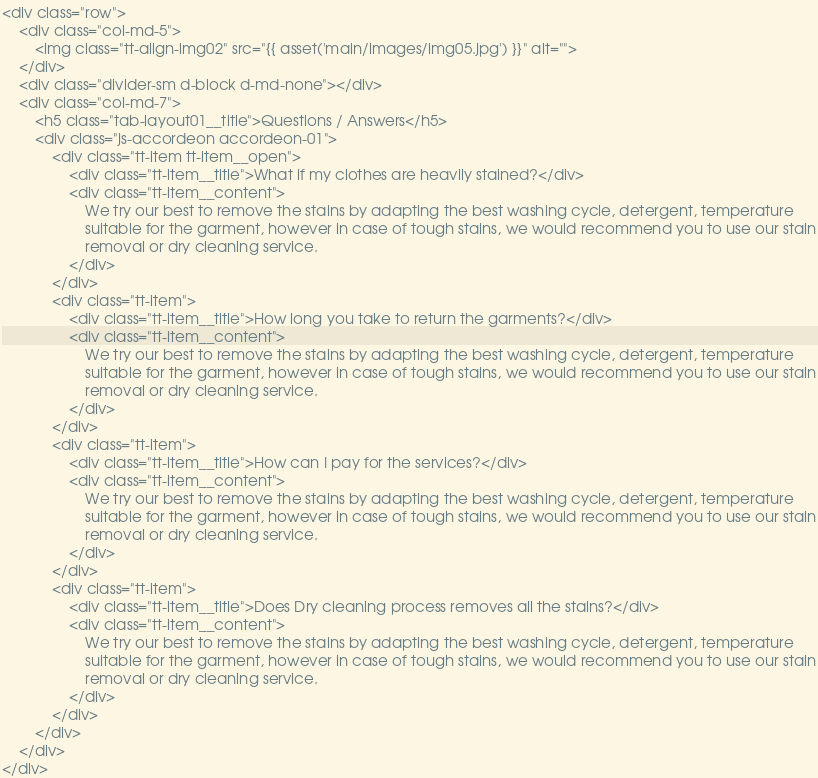<code> <loc_0><loc_0><loc_500><loc_500><_PHP_><div class="row">
    <div class="col-md-5">
        <img class="tt-align-img02" src="{{ asset('main/images/img05.jpg') }}" alt="">
    </div>
    <div class="divider-sm d-block d-md-none"></div>
    <div class="col-md-7">
        <h5 class="tab-layout01__title">Questions / Answers</h5>
        <div class="js-accordeon accordeon-01">
            <div class="tt-item tt-item__open">
                <div class="tt-item__title">What if my clothes are heavily stained?</div>
                <div class="tt-item__content">
                    We try our best to remove the stains by adapting the best washing cycle, detergent, temperature
                    suitable for the garment, however in case of tough stains, we would recommend you to use our stain
                    removal or dry cleaning service.
                </div>
            </div>
            <div class="tt-item">
                <div class="tt-item__title">How long you take to return the garments?</div>
                <div class="tt-item__content">
                    We try our best to remove the stains by adapting the best washing cycle, detergent, temperature
                    suitable for the garment, however in case of tough stains, we would recommend you to use our stain
                    removal or dry cleaning service.
                </div>
            </div>
            <div class="tt-item">
                <div class="tt-item__title">How can I pay for the services?</div>
                <div class="tt-item__content">
                    We try our best to remove the stains by adapting the best washing cycle, detergent, temperature
                    suitable for the garment, however in case of tough stains, we would recommend you to use our stain
                    removal or dry cleaning service.
                </div>
            </div>
            <div class="tt-item">
                <div class="tt-item__title">Does Dry cleaning process removes all the stains?</div>
                <div class="tt-item__content">
                    We try our best to remove the stains by adapting the best washing cycle, detergent, temperature
                    suitable for the garment, however in case of tough stains, we would recommend you to use our stain
                    removal or dry cleaning service.
                </div>
            </div>
        </div>
    </div>
</div>
</code> 